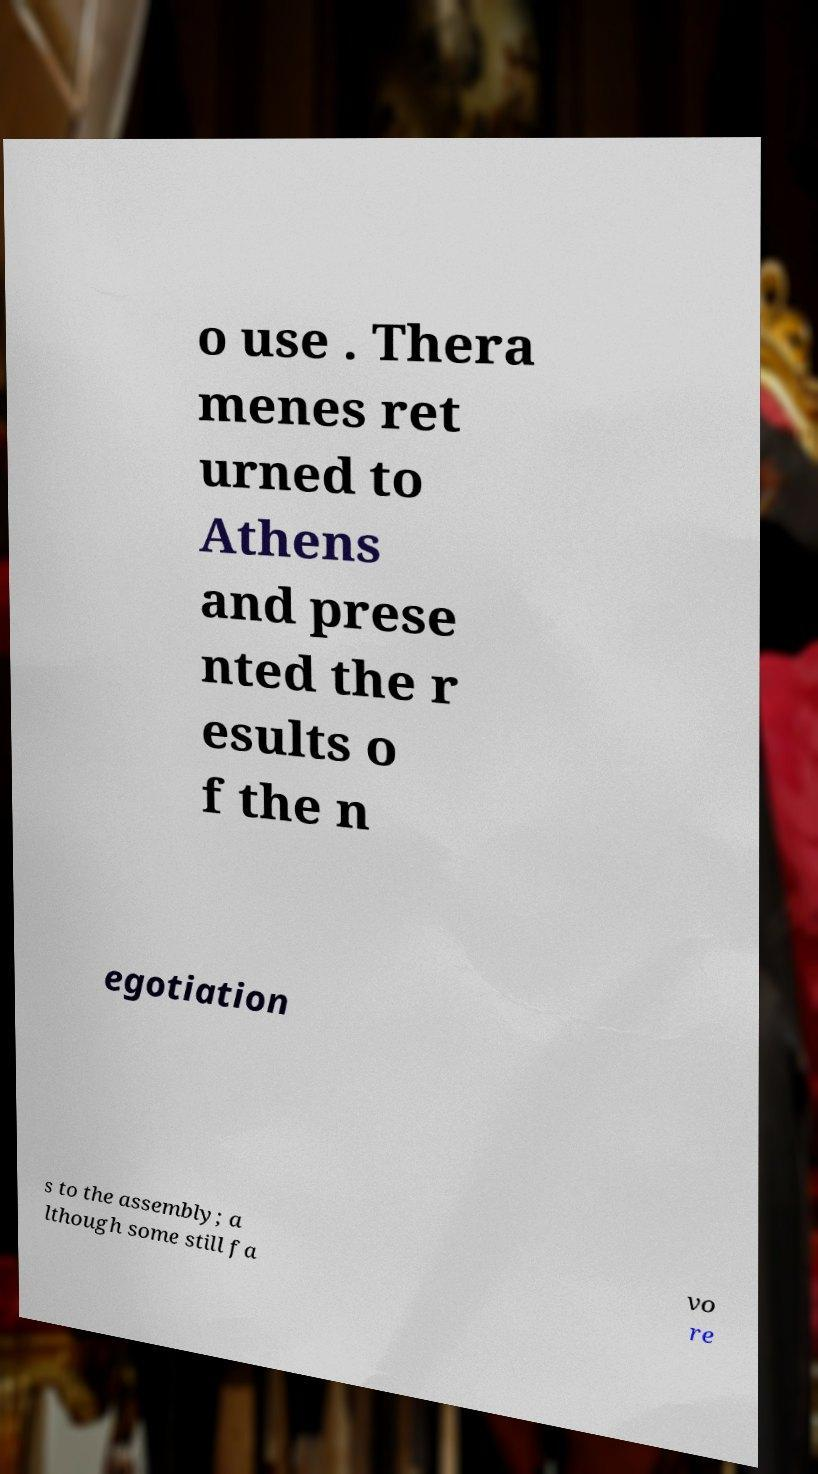What messages or text are displayed in this image? I need them in a readable, typed format. o use . Thera menes ret urned to Athens and prese nted the r esults o f the n egotiation s to the assembly; a lthough some still fa vo re 